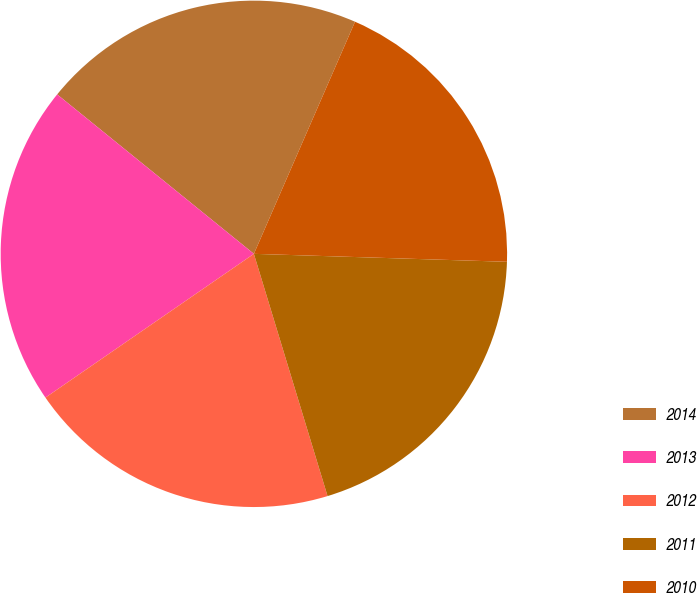Convert chart. <chart><loc_0><loc_0><loc_500><loc_500><pie_chart><fcel>2014<fcel>2013<fcel>2012<fcel>2011<fcel>2010<nl><fcel>20.7%<fcel>20.45%<fcel>20.09%<fcel>19.8%<fcel>18.96%<nl></chart> 